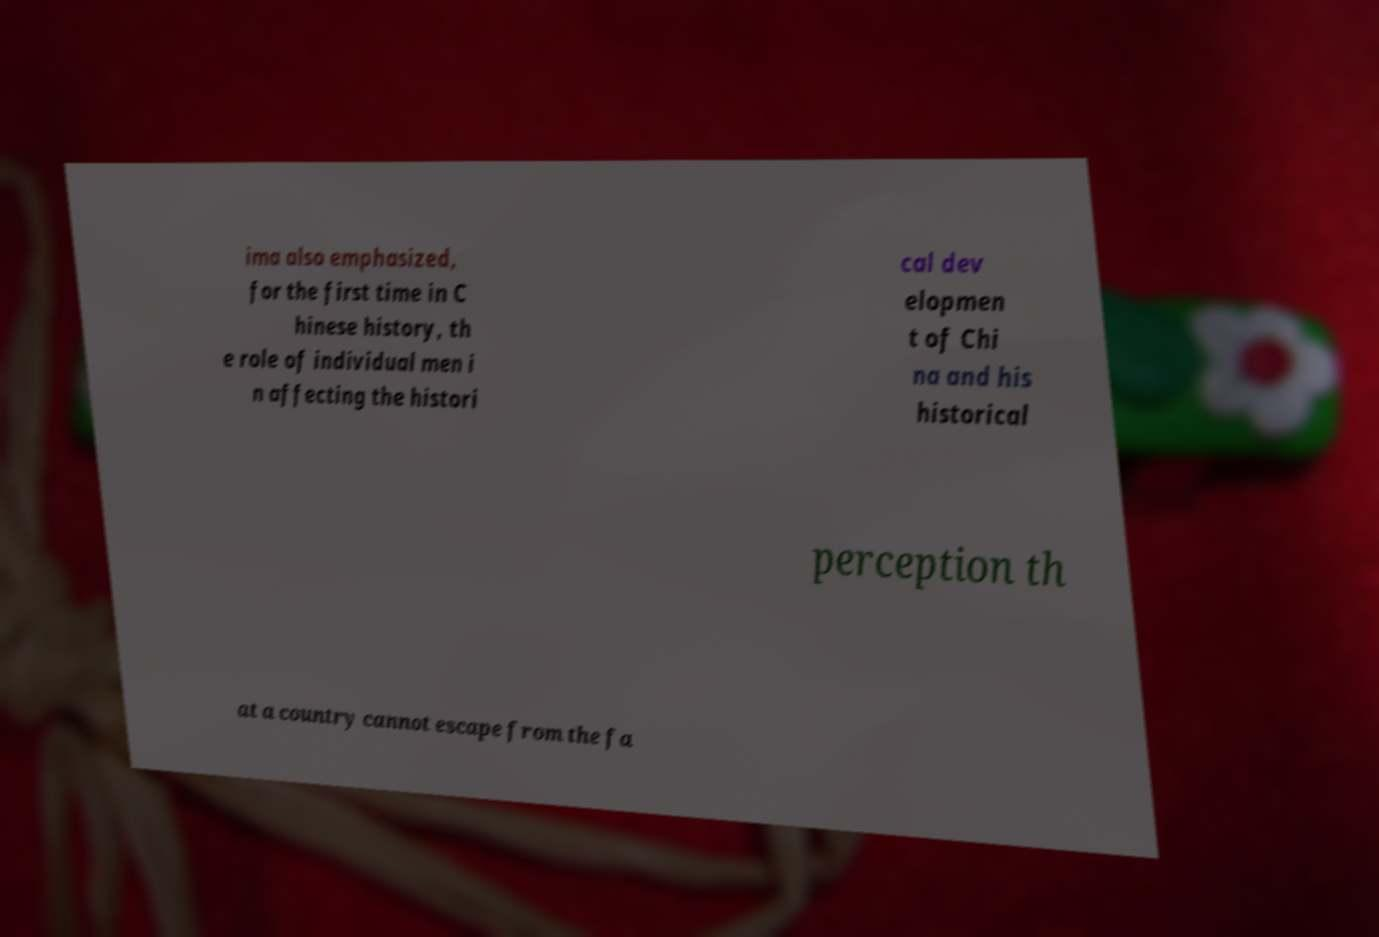Could you assist in decoding the text presented in this image and type it out clearly? ima also emphasized, for the first time in C hinese history, th e role of individual men i n affecting the histori cal dev elopmen t of Chi na and his historical perception th at a country cannot escape from the fa 